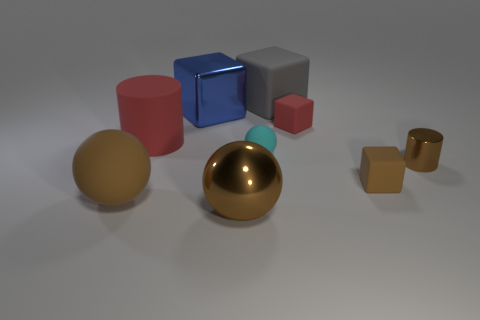Subtract all blue cubes. How many cubes are left? 3 Subtract all small red rubber blocks. How many blocks are left? 3 Subtract all green blocks. Subtract all yellow cylinders. How many blocks are left? 4 Subtract all balls. How many objects are left? 6 Add 8 tiny red rubber things. How many tiny red rubber things are left? 9 Add 9 tiny blue cylinders. How many tiny blue cylinders exist? 9 Subtract 0 green cubes. How many objects are left? 9 Subtract all spheres. Subtract all gray things. How many objects are left? 5 